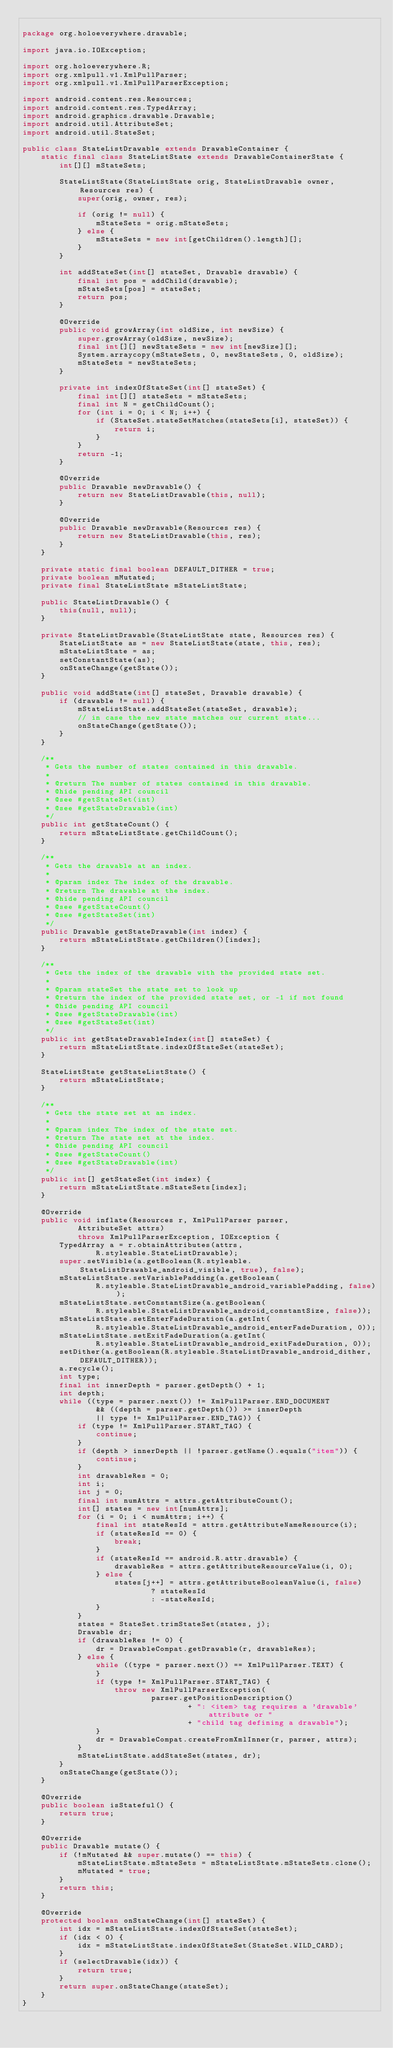<code> <loc_0><loc_0><loc_500><loc_500><_Java_>
package org.holoeverywhere.drawable;

import java.io.IOException;

import org.holoeverywhere.R;
import org.xmlpull.v1.XmlPullParser;
import org.xmlpull.v1.XmlPullParserException;

import android.content.res.Resources;
import android.content.res.TypedArray;
import android.graphics.drawable.Drawable;
import android.util.AttributeSet;
import android.util.StateSet;

public class StateListDrawable extends DrawableContainer {
    static final class StateListState extends DrawableContainerState {
        int[][] mStateSets;

        StateListState(StateListState orig, StateListDrawable owner, Resources res) {
            super(orig, owner, res);

            if (orig != null) {
                mStateSets = orig.mStateSets;
            } else {
                mStateSets = new int[getChildren().length][];
            }
        }

        int addStateSet(int[] stateSet, Drawable drawable) {
            final int pos = addChild(drawable);
            mStateSets[pos] = stateSet;
            return pos;
        }

        @Override
        public void growArray(int oldSize, int newSize) {
            super.growArray(oldSize, newSize);
            final int[][] newStateSets = new int[newSize][];
            System.arraycopy(mStateSets, 0, newStateSets, 0, oldSize);
            mStateSets = newStateSets;
        }

        private int indexOfStateSet(int[] stateSet) {
            final int[][] stateSets = mStateSets;
            final int N = getChildCount();
            for (int i = 0; i < N; i++) {
                if (StateSet.stateSetMatches(stateSets[i], stateSet)) {
                    return i;
                }
            }
            return -1;
        }

        @Override
        public Drawable newDrawable() {
            return new StateListDrawable(this, null);
        }

        @Override
        public Drawable newDrawable(Resources res) {
            return new StateListDrawable(this, res);
        }
    }

    private static final boolean DEFAULT_DITHER = true;
    private boolean mMutated;
    private final StateListState mStateListState;

    public StateListDrawable() {
        this(null, null);
    }

    private StateListDrawable(StateListState state, Resources res) {
        StateListState as = new StateListState(state, this, res);
        mStateListState = as;
        setConstantState(as);
        onStateChange(getState());
    }

    public void addState(int[] stateSet, Drawable drawable) {
        if (drawable != null) {
            mStateListState.addStateSet(stateSet, drawable);
            // in case the new state matches our current state...
            onStateChange(getState());
        }
    }

    /**
     * Gets the number of states contained in this drawable.
     * 
     * @return The number of states contained in this drawable.
     * @hide pending API council
     * @see #getStateSet(int)
     * @see #getStateDrawable(int)
     */
    public int getStateCount() {
        return mStateListState.getChildCount();
    }

    /**
     * Gets the drawable at an index.
     * 
     * @param index The index of the drawable.
     * @return The drawable at the index.
     * @hide pending API council
     * @see #getStateCount()
     * @see #getStateSet(int)
     */
    public Drawable getStateDrawable(int index) {
        return mStateListState.getChildren()[index];
    }

    /**
     * Gets the index of the drawable with the provided state set.
     * 
     * @param stateSet the state set to look up
     * @return the index of the provided state set, or -1 if not found
     * @hide pending API council
     * @see #getStateDrawable(int)
     * @see #getStateSet(int)
     */
    public int getStateDrawableIndex(int[] stateSet) {
        return mStateListState.indexOfStateSet(stateSet);
    }

    StateListState getStateListState() {
        return mStateListState;
    }

    /**
     * Gets the state set at an index.
     * 
     * @param index The index of the state set.
     * @return The state set at the index.
     * @hide pending API council
     * @see #getStateCount()
     * @see #getStateDrawable(int)
     */
    public int[] getStateSet(int index) {
        return mStateListState.mStateSets[index];
    }

    @Override
    public void inflate(Resources r, XmlPullParser parser,
            AttributeSet attrs)
            throws XmlPullParserException, IOException {
        TypedArray a = r.obtainAttributes(attrs,
                R.styleable.StateListDrawable);
        super.setVisible(a.getBoolean(R.styleable.StateListDrawable_android_visible, true), false);
        mStateListState.setVariablePadding(a.getBoolean(
                R.styleable.StateListDrawable_android_variablePadding, false));
        mStateListState.setConstantSize(a.getBoolean(
                R.styleable.StateListDrawable_android_constantSize, false));
        mStateListState.setEnterFadeDuration(a.getInt(
                R.styleable.StateListDrawable_android_enterFadeDuration, 0));
        mStateListState.setExitFadeDuration(a.getInt(
                R.styleable.StateListDrawable_android_exitFadeDuration, 0));
        setDither(a.getBoolean(R.styleable.StateListDrawable_android_dither, DEFAULT_DITHER));
        a.recycle();
        int type;
        final int innerDepth = parser.getDepth() + 1;
        int depth;
        while ((type = parser.next()) != XmlPullParser.END_DOCUMENT
                && ((depth = parser.getDepth()) >= innerDepth
                || type != XmlPullParser.END_TAG)) {
            if (type != XmlPullParser.START_TAG) {
                continue;
            }
            if (depth > innerDepth || !parser.getName().equals("item")) {
                continue;
            }
            int drawableRes = 0;
            int i;
            int j = 0;
            final int numAttrs = attrs.getAttributeCount();
            int[] states = new int[numAttrs];
            for (i = 0; i < numAttrs; i++) {
                final int stateResId = attrs.getAttributeNameResource(i);
                if (stateResId == 0) {
                    break;
                }
                if (stateResId == android.R.attr.drawable) {
                    drawableRes = attrs.getAttributeResourceValue(i, 0);
                } else {
                    states[j++] = attrs.getAttributeBooleanValue(i, false)
                            ? stateResId
                            : -stateResId;
                }
            }
            states = StateSet.trimStateSet(states, j);
            Drawable dr;
            if (drawableRes != 0) {
                dr = DrawableCompat.getDrawable(r, drawableRes);
            } else {
                while ((type = parser.next()) == XmlPullParser.TEXT) {
                }
                if (type != XmlPullParser.START_TAG) {
                    throw new XmlPullParserException(
                            parser.getPositionDescription()
                                    + ": <item> tag requires a 'drawable' attribute or "
                                    + "child tag defining a drawable");
                }
                dr = DrawableCompat.createFromXmlInner(r, parser, attrs);
            }
            mStateListState.addStateSet(states, dr);
        }
        onStateChange(getState());
    }

    @Override
    public boolean isStateful() {
        return true;
    }

    @Override
    public Drawable mutate() {
        if (!mMutated && super.mutate() == this) {
            mStateListState.mStateSets = mStateListState.mStateSets.clone();
            mMutated = true;
        }
        return this;
    }

    @Override
    protected boolean onStateChange(int[] stateSet) {
        int idx = mStateListState.indexOfStateSet(stateSet);
        if (idx < 0) {
            idx = mStateListState.indexOfStateSet(StateSet.WILD_CARD);
        }
        if (selectDrawable(idx)) {
            return true;
        }
        return super.onStateChange(stateSet);
    }
}
</code> 